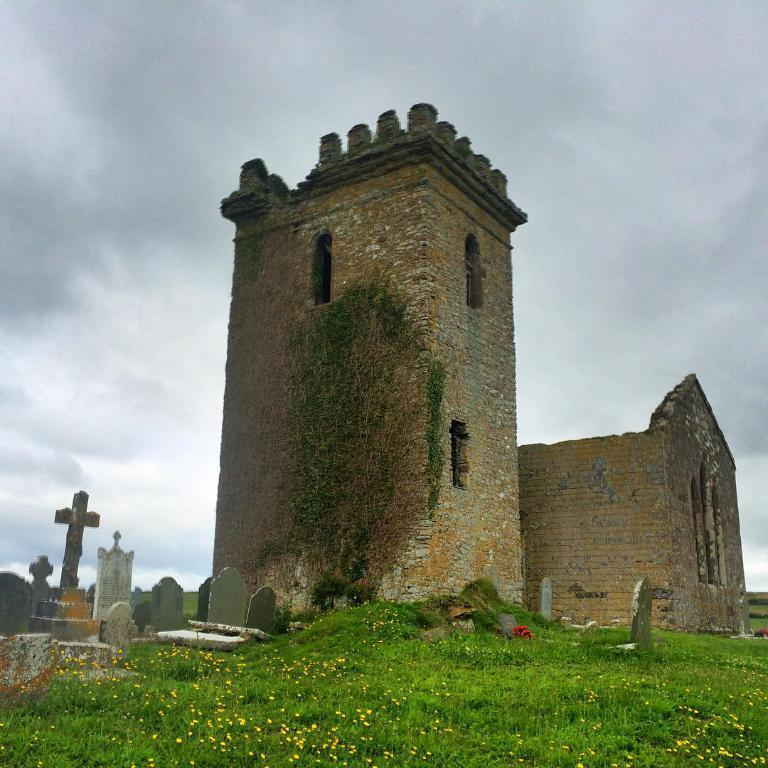What is the main structure in the image? There is a monument in the image. What is located near the monument? There is a graveyard beside the monument. What type of vegetation is present on the ground? There is grass on the ground. What can be seen in the background of the image? The sky is visible in the background of the image, and there are clouds in the sky. What is the level of the wrist in the image? There is no wrist present in the image, as it features a monument, a graveyard, grass, and a sky with clouds. 